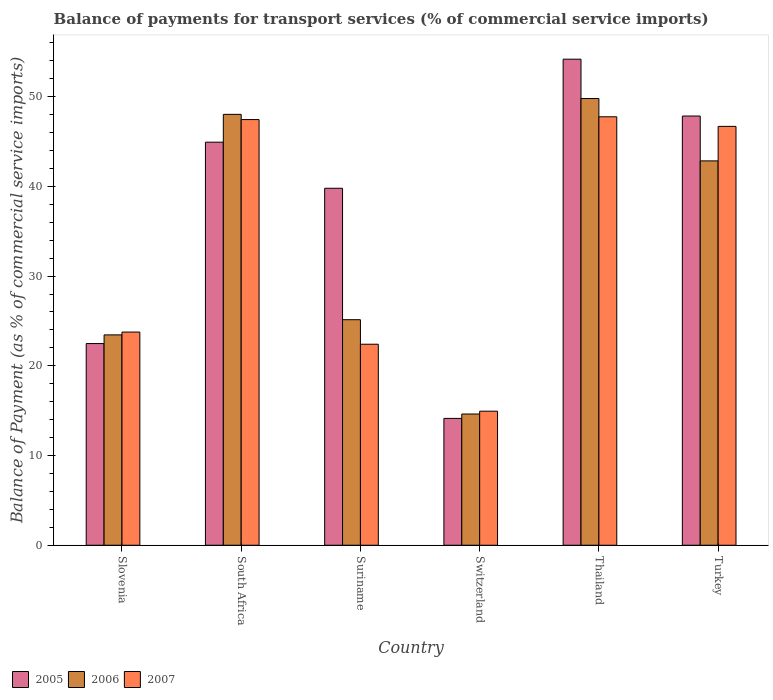How many groups of bars are there?
Offer a terse response. 6. Are the number of bars per tick equal to the number of legend labels?
Make the answer very short. Yes. How many bars are there on the 5th tick from the right?
Make the answer very short. 3. What is the label of the 4th group of bars from the left?
Your answer should be compact. Switzerland. In how many cases, is the number of bars for a given country not equal to the number of legend labels?
Your response must be concise. 0. What is the balance of payments for transport services in 2006 in South Africa?
Offer a terse response. 48.03. Across all countries, what is the maximum balance of payments for transport services in 2005?
Provide a succinct answer. 54.18. Across all countries, what is the minimum balance of payments for transport services in 2007?
Offer a terse response. 14.94. In which country was the balance of payments for transport services in 2006 maximum?
Offer a terse response. Thailand. In which country was the balance of payments for transport services in 2007 minimum?
Give a very brief answer. Switzerland. What is the total balance of payments for transport services in 2007 in the graph?
Offer a very short reply. 203. What is the difference between the balance of payments for transport services in 2006 in Switzerland and that in Turkey?
Make the answer very short. -28.21. What is the difference between the balance of payments for transport services in 2005 in Thailand and the balance of payments for transport services in 2007 in South Africa?
Give a very brief answer. 6.73. What is the average balance of payments for transport services in 2007 per country?
Offer a very short reply. 33.83. What is the difference between the balance of payments for transport services of/in 2006 and balance of payments for transport services of/in 2007 in Thailand?
Ensure brevity in your answer.  2.04. In how many countries, is the balance of payments for transport services in 2007 greater than 38 %?
Keep it short and to the point. 3. What is the ratio of the balance of payments for transport services in 2007 in Suriname to that in Turkey?
Ensure brevity in your answer.  0.48. Is the balance of payments for transport services in 2005 in Switzerland less than that in Turkey?
Offer a terse response. Yes. Is the difference between the balance of payments for transport services in 2006 in South Africa and Turkey greater than the difference between the balance of payments for transport services in 2007 in South Africa and Turkey?
Your answer should be very brief. Yes. What is the difference between the highest and the second highest balance of payments for transport services in 2006?
Your answer should be very brief. -1.77. What is the difference between the highest and the lowest balance of payments for transport services in 2007?
Your answer should be very brief. 32.82. In how many countries, is the balance of payments for transport services in 2007 greater than the average balance of payments for transport services in 2007 taken over all countries?
Keep it short and to the point. 3. What does the 2nd bar from the left in Slovenia represents?
Offer a terse response. 2006. How many bars are there?
Keep it short and to the point. 18. How many countries are there in the graph?
Offer a very short reply. 6. What is the difference between two consecutive major ticks on the Y-axis?
Your response must be concise. 10. Are the values on the major ticks of Y-axis written in scientific E-notation?
Your response must be concise. No. Where does the legend appear in the graph?
Keep it short and to the point. Bottom left. How many legend labels are there?
Give a very brief answer. 3. How are the legend labels stacked?
Offer a very short reply. Horizontal. What is the title of the graph?
Your response must be concise. Balance of payments for transport services (% of commercial service imports). What is the label or title of the Y-axis?
Your answer should be very brief. Balance of Payment (as % of commercial service imports). What is the Balance of Payment (as % of commercial service imports) of 2005 in Slovenia?
Provide a succinct answer. 22.48. What is the Balance of Payment (as % of commercial service imports) of 2006 in Slovenia?
Keep it short and to the point. 23.45. What is the Balance of Payment (as % of commercial service imports) of 2007 in Slovenia?
Your answer should be very brief. 23.76. What is the Balance of Payment (as % of commercial service imports) of 2005 in South Africa?
Ensure brevity in your answer.  44.93. What is the Balance of Payment (as % of commercial service imports) of 2006 in South Africa?
Your response must be concise. 48.03. What is the Balance of Payment (as % of commercial service imports) of 2007 in South Africa?
Provide a short and direct response. 47.45. What is the Balance of Payment (as % of commercial service imports) in 2005 in Suriname?
Your response must be concise. 39.79. What is the Balance of Payment (as % of commercial service imports) in 2006 in Suriname?
Offer a very short reply. 25.14. What is the Balance of Payment (as % of commercial service imports) in 2007 in Suriname?
Keep it short and to the point. 22.41. What is the Balance of Payment (as % of commercial service imports) in 2005 in Switzerland?
Ensure brevity in your answer.  14.14. What is the Balance of Payment (as % of commercial service imports) in 2006 in Switzerland?
Offer a terse response. 14.63. What is the Balance of Payment (as % of commercial service imports) in 2007 in Switzerland?
Offer a very short reply. 14.94. What is the Balance of Payment (as % of commercial service imports) in 2005 in Thailand?
Your answer should be very brief. 54.18. What is the Balance of Payment (as % of commercial service imports) of 2006 in Thailand?
Your answer should be compact. 49.79. What is the Balance of Payment (as % of commercial service imports) of 2007 in Thailand?
Provide a succinct answer. 47.76. What is the Balance of Payment (as % of commercial service imports) of 2005 in Turkey?
Give a very brief answer. 47.84. What is the Balance of Payment (as % of commercial service imports) of 2006 in Turkey?
Make the answer very short. 42.84. What is the Balance of Payment (as % of commercial service imports) in 2007 in Turkey?
Offer a very short reply. 46.69. Across all countries, what is the maximum Balance of Payment (as % of commercial service imports) of 2005?
Give a very brief answer. 54.18. Across all countries, what is the maximum Balance of Payment (as % of commercial service imports) in 2006?
Offer a very short reply. 49.79. Across all countries, what is the maximum Balance of Payment (as % of commercial service imports) of 2007?
Make the answer very short. 47.76. Across all countries, what is the minimum Balance of Payment (as % of commercial service imports) of 2005?
Offer a terse response. 14.14. Across all countries, what is the minimum Balance of Payment (as % of commercial service imports) of 2006?
Give a very brief answer. 14.63. Across all countries, what is the minimum Balance of Payment (as % of commercial service imports) of 2007?
Provide a short and direct response. 14.94. What is the total Balance of Payment (as % of commercial service imports) of 2005 in the graph?
Offer a very short reply. 223.36. What is the total Balance of Payment (as % of commercial service imports) of 2006 in the graph?
Your answer should be compact. 203.88. What is the total Balance of Payment (as % of commercial service imports) of 2007 in the graph?
Ensure brevity in your answer.  203. What is the difference between the Balance of Payment (as % of commercial service imports) of 2005 in Slovenia and that in South Africa?
Offer a very short reply. -22.45. What is the difference between the Balance of Payment (as % of commercial service imports) of 2006 in Slovenia and that in South Africa?
Offer a very short reply. -24.58. What is the difference between the Balance of Payment (as % of commercial service imports) of 2007 in Slovenia and that in South Africa?
Make the answer very short. -23.69. What is the difference between the Balance of Payment (as % of commercial service imports) of 2005 in Slovenia and that in Suriname?
Provide a succinct answer. -17.31. What is the difference between the Balance of Payment (as % of commercial service imports) in 2006 in Slovenia and that in Suriname?
Your answer should be very brief. -1.69. What is the difference between the Balance of Payment (as % of commercial service imports) of 2007 in Slovenia and that in Suriname?
Your answer should be compact. 1.35. What is the difference between the Balance of Payment (as % of commercial service imports) in 2005 in Slovenia and that in Switzerland?
Offer a very short reply. 8.34. What is the difference between the Balance of Payment (as % of commercial service imports) in 2006 in Slovenia and that in Switzerland?
Offer a very short reply. 8.82. What is the difference between the Balance of Payment (as % of commercial service imports) of 2007 in Slovenia and that in Switzerland?
Provide a succinct answer. 8.82. What is the difference between the Balance of Payment (as % of commercial service imports) of 2005 in Slovenia and that in Thailand?
Make the answer very short. -31.7. What is the difference between the Balance of Payment (as % of commercial service imports) in 2006 in Slovenia and that in Thailand?
Offer a terse response. -26.35. What is the difference between the Balance of Payment (as % of commercial service imports) of 2007 in Slovenia and that in Thailand?
Make the answer very short. -24. What is the difference between the Balance of Payment (as % of commercial service imports) in 2005 in Slovenia and that in Turkey?
Your answer should be compact. -25.36. What is the difference between the Balance of Payment (as % of commercial service imports) in 2006 in Slovenia and that in Turkey?
Your response must be concise. -19.4. What is the difference between the Balance of Payment (as % of commercial service imports) in 2007 in Slovenia and that in Turkey?
Offer a terse response. -22.93. What is the difference between the Balance of Payment (as % of commercial service imports) of 2005 in South Africa and that in Suriname?
Keep it short and to the point. 5.14. What is the difference between the Balance of Payment (as % of commercial service imports) in 2006 in South Africa and that in Suriname?
Ensure brevity in your answer.  22.89. What is the difference between the Balance of Payment (as % of commercial service imports) of 2007 in South Africa and that in Suriname?
Your answer should be very brief. 25.04. What is the difference between the Balance of Payment (as % of commercial service imports) in 2005 in South Africa and that in Switzerland?
Provide a succinct answer. 30.79. What is the difference between the Balance of Payment (as % of commercial service imports) in 2006 in South Africa and that in Switzerland?
Give a very brief answer. 33.4. What is the difference between the Balance of Payment (as % of commercial service imports) in 2007 in South Africa and that in Switzerland?
Ensure brevity in your answer.  32.51. What is the difference between the Balance of Payment (as % of commercial service imports) of 2005 in South Africa and that in Thailand?
Your answer should be compact. -9.25. What is the difference between the Balance of Payment (as % of commercial service imports) of 2006 in South Africa and that in Thailand?
Offer a very short reply. -1.77. What is the difference between the Balance of Payment (as % of commercial service imports) in 2007 in South Africa and that in Thailand?
Keep it short and to the point. -0.31. What is the difference between the Balance of Payment (as % of commercial service imports) in 2005 in South Africa and that in Turkey?
Your response must be concise. -2.91. What is the difference between the Balance of Payment (as % of commercial service imports) in 2006 in South Africa and that in Turkey?
Your answer should be very brief. 5.19. What is the difference between the Balance of Payment (as % of commercial service imports) in 2007 in South Africa and that in Turkey?
Your answer should be very brief. 0.76. What is the difference between the Balance of Payment (as % of commercial service imports) of 2005 in Suriname and that in Switzerland?
Provide a short and direct response. 25.65. What is the difference between the Balance of Payment (as % of commercial service imports) of 2006 in Suriname and that in Switzerland?
Provide a succinct answer. 10.51. What is the difference between the Balance of Payment (as % of commercial service imports) of 2007 in Suriname and that in Switzerland?
Offer a very short reply. 7.46. What is the difference between the Balance of Payment (as % of commercial service imports) in 2005 in Suriname and that in Thailand?
Offer a terse response. -14.39. What is the difference between the Balance of Payment (as % of commercial service imports) in 2006 in Suriname and that in Thailand?
Your response must be concise. -24.65. What is the difference between the Balance of Payment (as % of commercial service imports) in 2007 in Suriname and that in Thailand?
Give a very brief answer. -25.35. What is the difference between the Balance of Payment (as % of commercial service imports) in 2005 in Suriname and that in Turkey?
Your response must be concise. -8.05. What is the difference between the Balance of Payment (as % of commercial service imports) in 2006 in Suriname and that in Turkey?
Offer a terse response. -17.7. What is the difference between the Balance of Payment (as % of commercial service imports) in 2007 in Suriname and that in Turkey?
Ensure brevity in your answer.  -24.28. What is the difference between the Balance of Payment (as % of commercial service imports) in 2005 in Switzerland and that in Thailand?
Give a very brief answer. -40.04. What is the difference between the Balance of Payment (as % of commercial service imports) in 2006 in Switzerland and that in Thailand?
Keep it short and to the point. -35.17. What is the difference between the Balance of Payment (as % of commercial service imports) of 2007 in Switzerland and that in Thailand?
Give a very brief answer. -32.82. What is the difference between the Balance of Payment (as % of commercial service imports) of 2005 in Switzerland and that in Turkey?
Give a very brief answer. -33.7. What is the difference between the Balance of Payment (as % of commercial service imports) of 2006 in Switzerland and that in Turkey?
Your response must be concise. -28.21. What is the difference between the Balance of Payment (as % of commercial service imports) in 2007 in Switzerland and that in Turkey?
Your answer should be compact. -31.75. What is the difference between the Balance of Payment (as % of commercial service imports) in 2005 in Thailand and that in Turkey?
Provide a short and direct response. 6.34. What is the difference between the Balance of Payment (as % of commercial service imports) in 2006 in Thailand and that in Turkey?
Provide a succinct answer. 6.95. What is the difference between the Balance of Payment (as % of commercial service imports) of 2007 in Thailand and that in Turkey?
Make the answer very short. 1.07. What is the difference between the Balance of Payment (as % of commercial service imports) in 2005 in Slovenia and the Balance of Payment (as % of commercial service imports) in 2006 in South Africa?
Make the answer very short. -25.55. What is the difference between the Balance of Payment (as % of commercial service imports) of 2005 in Slovenia and the Balance of Payment (as % of commercial service imports) of 2007 in South Africa?
Your answer should be very brief. -24.97. What is the difference between the Balance of Payment (as % of commercial service imports) of 2006 in Slovenia and the Balance of Payment (as % of commercial service imports) of 2007 in South Africa?
Ensure brevity in your answer.  -24. What is the difference between the Balance of Payment (as % of commercial service imports) of 2005 in Slovenia and the Balance of Payment (as % of commercial service imports) of 2006 in Suriname?
Make the answer very short. -2.66. What is the difference between the Balance of Payment (as % of commercial service imports) in 2005 in Slovenia and the Balance of Payment (as % of commercial service imports) in 2007 in Suriname?
Offer a very short reply. 0.07. What is the difference between the Balance of Payment (as % of commercial service imports) in 2006 in Slovenia and the Balance of Payment (as % of commercial service imports) in 2007 in Suriname?
Give a very brief answer. 1.04. What is the difference between the Balance of Payment (as % of commercial service imports) of 2005 in Slovenia and the Balance of Payment (as % of commercial service imports) of 2006 in Switzerland?
Make the answer very short. 7.85. What is the difference between the Balance of Payment (as % of commercial service imports) in 2005 in Slovenia and the Balance of Payment (as % of commercial service imports) in 2007 in Switzerland?
Offer a very short reply. 7.54. What is the difference between the Balance of Payment (as % of commercial service imports) in 2006 in Slovenia and the Balance of Payment (as % of commercial service imports) in 2007 in Switzerland?
Your response must be concise. 8.51. What is the difference between the Balance of Payment (as % of commercial service imports) of 2005 in Slovenia and the Balance of Payment (as % of commercial service imports) of 2006 in Thailand?
Your answer should be very brief. -27.31. What is the difference between the Balance of Payment (as % of commercial service imports) of 2005 in Slovenia and the Balance of Payment (as % of commercial service imports) of 2007 in Thailand?
Keep it short and to the point. -25.28. What is the difference between the Balance of Payment (as % of commercial service imports) of 2006 in Slovenia and the Balance of Payment (as % of commercial service imports) of 2007 in Thailand?
Your answer should be very brief. -24.31. What is the difference between the Balance of Payment (as % of commercial service imports) of 2005 in Slovenia and the Balance of Payment (as % of commercial service imports) of 2006 in Turkey?
Your answer should be compact. -20.36. What is the difference between the Balance of Payment (as % of commercial service imports) of 2005 in Slovenia and the Balance of Payment (as % of commercial service imports) of 2007 in Turkey?
Offer a terse response. -24.21. What is the difference between the Balance of Payment (as % of commercial service imports) of 2006 in Slovenia and the Balance of Payment (as % of commercial service imports) of 2007 in Turkey?
Make the answer very short. -23.24. What is the difference between the Balance of Payment (as % of commercial service imports) in 2005 in South Africa and the Balance of Payment (as % of commercial service imports) in 2006 in Suriname?
Give a very brief answer. 19.79. What is the difference between the Balance of Payment (as % of commercial service imports) in 2005 in South Africa and the Balance of Payment (as % of commercial service imports) in 2007 in Suriname?
Keep it short and to the point. 22.52. What is the difference between the Balance of Payment (as % of commercial service imports) of 2006 in South Africa and the Balance of Payment (as % of commercial service imports) of 2007 in Suriname?
Your answer should be compact. 25.62. What is the difference between the Balance of Payment (as % of commercial service imports) of 2005 in South Africa and the Balance of Payment (as % of commercial service imports) of 2006 in Switzerland?
Provide a succinct answer. 30.3. What is the difference between the Balance of Payment (as % of commercial service imports) of 2005 in South Africa and the Balance of Payment (as % of commercial service imports) of 2007 in Switzerland?
Your answer should be very brief. 29.99. What is the difference between the Balance of Payment (as % of commercial service imports) in 2006 in South Africa and the Balance of Payment (as % of commercial service imports) in 2007 in Switzerland?
Your answer should be compact. 33.09. What is the difference between the Balance of Payment (as % of commercial service imports) in 2005 in South Africa and the Balance of Payment (as % of commercial service imports) in 2006 in Thailand?
Your answer should be very brief. -4.87. What is the difference between the Balance of Payment (as % of commercial service imports) of 2005 in South Africa and the Balance of Payment (as % of commercial service imports) of 2007 in Thailand?
Your answer should be very brief. -2.83. What is the difference between the Balance of Payment (as % of commercial service imports) in 2006 in South Africa and the Balance of Payment (as % of commercial service imports) in 2007 in Thailand?
Give a very brief answer. 0.27. What is the difference between the Balance of Payment (as % of commercial service imports) in 2005 in South Africa and the Balance of Payment (as % of commercial service imports) in 2006 in Turkey?
Give a very brief answer. 2.09. What is the difference between the Balance of Payment (as % of commercial service imports) of 2005 in South Africa and the Balance of Payment (as % of commercial service imports) of 2007 in Turkey?
Your response must be concise. -1.76. What is the difference between the Balance of Payment (as % of commercial service imports) of 2006 in South Africa and the Balance of Payment (as % of commercial service imports) of 2007 in Turkey?
Your response must be concise. 1.34. What is the difference between the Balance of Payment (as % of commercial service imports) in 2005 in Suriname and the Balance of Payment (as % of commercial service imports) in 2006 in Switzerland?
Offer a terse response. 25.16. What is the difference between the Balance of Payment (as % of commercial service imports) of 2005 in Suriname and the Balance of Payment (as % of commercial service imports) of 2007 in Switzerland?
Provide a succinct answer. 24.85. What is the difference between the Balance of Payment (as % of commercial service imports) in 2006 in Suriname and the Balance of Payment (as % of commercial service imports) in 2007 in Switzerland?
Offer a very short reply. 10.2. What is the difference between the Balance of Payment (as % of commercial service imports) of 2005 in Suriname and the Balance of Payment (as % of commercial service imports) of 2006 in Thailand?
Offer a very short reply. -10. What is the difference between the Balance of Payment (as % of commercial service imports) of 2005 in Suriname and the Balance of Payment (as % of commercial service imports) of 2007 in Thailand?
Ensure brevity in your answer.  -7.97. What is the difference between the Balance of Payment (as % of commercial service imports) in 2006 in Suriname and the Balance of Payment (as % of commercial service imports) in 2007 in Thailand?
Provide a succinct answer. -22.62. What is the difference between the Balance of Payment (as % of commercial service imports) of 2005 in Suriname and the Balance of Payment (as % of commercial service imports) of 2006 in Turkey?
Ensure brevity in your answer.  -3.05. What is the difference between the Balance of Payment (as % of commercial service imports) of 2005 in Suriname and the Balance of Payment (as % of commercial service imports) of 2007 in Turkey?
Provide a succinct answer. -6.9. What is the difference between the Balance of Payment (as % of commercial service imports) of 2006 in Suriname and the Balance of Payment (as % of commercial service imports) of 2007 in Turkey?
Your answer should be very brief. -21.55. What is the difference between the Balance of Payment (as % of commercial service imports) in 2005 in Switzerland and the Balance of Payment (as % of commercial service imports) in 2006 in Thailand?
Give a very brief answer. -35.66. What is the difference between the Balance of Payment (as % of commercial service imports) of 2005 in Switzerland and the Balance of Payment (as % of commercial service imports) of 2007 in Thailand?
Offer a very short reply. -33.62. What is the difference between the Balance of Payment (as % of commercial service imports) in 2006 in Switzerland and the Balance of Payment (as % of commercial service imports) in 2007 in Thailand?
Provide a short and direct response. -33.13. What is the difference between the Balance of Payment (as % of commercial service imports) of 2005 in Switzerland and the Balance of Payment (as % of commercial service imports) of 2006 in Turkey?
Make the answer very short. -28.7. What is the difference between the Balance of Payment (as % of commercial service imports) of 2005 in Switzerland and the Balance of Payment (as % of commercial service imports) of 2007 in Turkey?
Keep it short and to the point. -32.55. What is the difference between the Balance of Payment (as % of commercial service imports) of 2006 in Switzerland and the Balance of Payment (as % of commercial service imports) of 2007 in Turkey?
Keep it short and to the point. -32.06. What is the difference between the Balance of Payment (as % of commercial service imports) in 2005 in Thailand and the Balance of Payment (as % of commercial service imports) in 2006 in Turkey?
Make the answer very short. 11.34. What is the difference between the Balance of Payment (as % of commercial service imports) of 2005 in Thailand and the Balance of Payment (as % of commercial service imports) of 2007 in Turkey?
Your answer should be compact. 7.49. What is the difference between the Balance of Payment (as % of commercial service imports) in 2006 in Thailand and the Balance of Payment (as % of commercial service imports) in 2007 in Turkey?
Give a very brief answer. 3.11. What is the average Balance of Payment (as % of commercial service imports) in 2005 per country?
Provide a succinct answer. 37.23. What is the average Balance of Payment (as % of commercial service imports) of 2006 per country?
Your answer should be compact. 33.98. What is the average Balance of Payment (as % of commercial service imports) of 2007 per country?
Provide a succinct answer. 33.83. What is the difference between the Balance of Payment (as % of commercial service imports) in 2005 and Balance of Payment (as % of commercial service imports) in 2006 in Slovenia?
Provide a succinct answer. -0.97. What is the difference between the Balance of Payment (as % of commercial service imports) of 2005 and Balance of Payment (as % of commercial service imports) of 2007 in Slovenia?
Make the answer very short. -1.28. What is the difference between the Balance of Payment (as % of commercial service imports) in 2006 and Balance of Payment (as % of commercial service imports) in 2007 in Slovenia?
Make the answer very short. -0.31. What is the difference between the Balance of Payment (as % of commercial service imports) in 2005 and Balance of Payment (as % of commercial service imports) in 2006 in South Africa?
Offer a terse response. -3.1. What is the difference between the Balance of Payment (as % of commercial service imports) of 2005 and Balance of Payment (as % of commercial service imports) of 2007 in South Africa?
Your answer should be very brief. -2.52. What is the difference between the Balance of Payment (as % of commercial service imports) in 2006 and Balance of Payment (as % of commercial service imports) in 2007 in South Africa?
Provide a succinct answer. 0.58. What is the difference between the Balance of Payment (as % of commercial service imports) in 2005 and Balance of Payment (as % of commercial service imports) in 2006 in Suriname?
Give a very brief answer. 14.65. What is the difference between the Balance of Payment (as % of commercial service imports) of 2005 and Balance of Payment (as % of commercial service imports) of 2007 in Suriname?
Keep it short and to the point. 17.38. What is the difference between the Balance of Payment (as % of commercial service imports) in 2006 and Balance of Payment (as % of commercial service imports) in 2007 in Suriname?
Provide a short and direct response. 2.73. What is the difference between the Balance of Payment (as % of commercial service imports) of 2005 and Balance of Payment (as % of commercial service imports) of 2006 in Switzerland?
Provide a short and direct response. -0.49. What is the difference between the Balance of Payment (as % of commercial service imports) of 2005 and Balance of Payment (as % of commercial service imports) of 2007 in Switzerland?
Offer a very short reply. -0.8. What is the difference between the Balance of Payment (as % of commercial service imports) of 2006 and Balance of Payment (as % of commercial service imports) of 2007 in Switzerland?
Your response must be concise. -0.31. What is the difference between the Balance of Payment (as % of commercial service imports) of 2005 and Balance of Payment (as % of commercial service imports) of 2006 in Thailand?
Make the answer very short. 4.39. What is the difference between the Balance of Payment (as % of commercial service imports) in 2005 and Balance of Payment (as % of commercial service imports) in 2007 in Thailand?
Keep it short and to the point. 6.42. What is the difference between the Balance of Payment (as % of commercial service imports) in 2006 and Balance of Payment (as % of commercial service imports) in 2007 in Thailand?
Your response must be concise. 2.04. What is the difference between the Balance of Payment (as % of commercial service imports) of 2005 and Balance of Payment (as % of commercial service imports) of 2006 in Turkey?
Ensure brevity in your answer.  5. What is the difference between the Balance of Payment (as % of commercial service imports) of 2005 and Balance of Payment (as % of commercial service imports) of 2007 in Turkey?
Offer a terse response. 1.15. What is the difference between the Balance of Payment (as % of commercial service imports) in 2006 and Balance of Payment (as % of commercial service imports) in 2007 in Turkey?
Your answer should be compact. -3.85. What is the ratio of the Balance of Payment (as % of commercial service imports) in 2005 in Slovenia to that in South Africa?
Give a very brief answer. 0.5. What is the ratio of the Balance of Payment (as % of commercial service imports) of 2006 in Slovenia to that in South Africa?
Keep it short and to the point. 0.49. What is the ratio of the Balance of Payment (as % of commercial service imports) of 2007 in Slovenia to that in South Africa?
Your answer should be compact. 0.5. What is the ratio of the Balance of Payment (as % of commercial service imports) in 2005 in Slovenia to that in Suriname?
Keep it short and to the point. 0.56. What is the ratio of the Balance of Payment (as % of commercial service imports) of 2006 in Slovenia to that in Suriname?
Offer a terse response. 0.93. What is the ratio of the Balance of Payment (as % of commercial service imports) of 2007 in Slovenia to that in Suriname?
Your response must be concise. 1.06. What is the ratio of the Balance of Payment (as % of commercial service imports) of 2005 in Slovenia to that in Switzerland?
Ensure brevity in your answer.  1.59. What is the ratio of the Balance of Payment (as % of commercial service imports) of 2006 in Slovenia to that in Switzerland?
Keep it short and to the point. 1.6. What is the ratio of the Balance of Payment (as % of commercial service imports) in 2007 in Slovenia to that in Switzerland?
Your response must be concise. 1.59. What is the ratio of the Balance of Payment (as % of commercial service imports) in 2005 in Slovenia to that in Thailand?
Ensure brevity in your answer.  0.41. What is the ratio of the Balance of Payment (as % of commercial service imports) in 2006 in Slovenia to that in Thailand?
Your answer should be very brief. 0.47. What is the ratio of the Balance of Payment (as % of commercial service imports) of 2007 in Slovenia to that in Thailand?
Offer a terse response. 0.5. What is the ratio of the Balance of Payment (as % of commercial service imports) of 2005 in Slovenia to that in Turkey?
Offer a terse response. 0.47. What is the ratio of the Balance of Payment (as % of commercial service imports) of 2006 in Slovenia to that in Turkey?
Offer a very short reply. 0.55. What is the ratio of the Balance of Payment (as % of commercial service imports) of 2007 in Slovenia to that in Turkey?
Offer a very short reply. 0.51. What is the ratio of the Balance of Payment (as % of commercial service imports) in 2005 in South Africa to that in Suriname?
Your response must be concise. 1.13. What is the ratio of the Balance of Payment (as % of commercial service imports) of 2006 in South Africa to that in Suriname?
Offer a very short reply. 1.91. What is the ratio of the Balance of Payment (as % of commercial service imports) in 2007 in South Africa to that in Suriname?
Keep it short and to the point. 2.12. What is the ratio of the Balance of Payment (as % of commercial service imports) of 2005 in South Africa to that in Switzerland?
Give a very brief answer. 3.18. What is the ratio of the Balance of Payment (as % of commercial service imports) in 2006 in South Africa to that in Switzerland?
Your answer should be very brief. 3.28. What is the ratio of the Balance of Payment (as % of commercial service imports) of 2007 in South Africa to that in Switzerland?
Your answer should be very brief. 3.18. What is the ratio of the Balance of Payment (as % of commercial service imports) in 2005 in South Africa to that in Thailand?
Keep it short and to the point. 0.83. What is the ratio of the Balance of Payment (as % of commercial service imports) of 2006 in South Africa to that in Thailand?
Provide a succinct answer. 0.96. What is the ratio of the Balance of Payment (as % of commercial service imports) in 2007 in South Africa to that in Thailand?
Offer a terse response. 0.99. What is the ratio of the Balance of Payment (as % of commercial service imports) in 2005 in South Africa to that in Turkey?
Provide a succinct answer. 0.94. What is the ratio of the Balance of Payment (as % of commercial service imports) of 2006 in South Africa to that in Turkey?
Provide a succinct answer. 1.12. What is the ratio of the Balance of Payment (as % of commercial service imports) of 2007 in South Africa to that in Turkey?
Ensure brevity in your answer.  1.02. What is the ratio of the Balance of Payment (as % of commercial service imports) in 2005 in Suriname to that in Switzerland?
Give a very brief answer. 2.81. What is the ratio of the Balance of Payment (as % of commercial service imports) of 2006 in Suriname to that in Switzerland?
Provide a succinct answer. 1.72. What is the ratio of the Balance of Payment (as % of commercial service imports) in 2007 in Suriname to that in Switzerland?
Your answer should be very brief. 1.5. What is the ratio of the Balance of Payment (as % of commercial service imports) in 2005 in Suriname to that in Thailand?
Your response must be concise. 0.73. What is the ratio of the Balance of Payment (as % of commercial service imports) in 2006 in Suriname to that in Thailand?
Your answer should be compact. 0.5. What is the ratio of the Balance of Payment (as % of commercial service imports) of 2007 in Suriname to that in Thailand?
Ensure brevity in your answer.  0.47. What is the ratio of the Balance of Payment (as % of commercial service imports) in 2005 in Suriname to that in Turkey?
Offer a very short reply. 0.83. What is the ratio of the Balance of Payment (as % of commercial service imports) in 2006 in Suriname to that in Turkey?
Provide a short and direct response. 0.59. What is the ratio of the Balance of Payment (as % of commercial service imports) of 2007 in Suriname to that in Turkey?
Make the answer very short. 0.48. What is the ratio of the Balance of Payment (as % of commercial service imports) in 2005 in Switzerland to that in Thailand?
Give a very brief answer. 0.26. What is the ratio of the Balance of Payment (as % of commercial service imports) of 2006 in Switzerland to that in Thailand?
Your response must be concise. 0.29. What is the ratio of the Balance of Payment (as % of commercial service imports) of 2007 in Switzerland to that in Thailand?
Give a very brief answer. 0.31. What is the ratio of the Balance of Payment (as % of commercial service imports) in 2005 in Switzerland to that in Turkey?
Give a very brief answer. 0.3. What is the ratio of the Balance of Payment (as % of commercial service imports) of 2006 in Switzerland to that in Turkey?
Give a very brief answer. 0.34. What is the ratio of the Balance of Payment (as % of commercial service imports) of 2007 in Switzerland to that in Turkey?
Offer a terse response. 0.32. What is the ratio of the Balance of Payment (as % of commercial service imports) of 2005 in Thailand to that in Turkey?
Give a very brief answer. 1.13. What is the ratio of the Balance of Payment (as % of commercial service imports) of 2006 in Thailand to that in Turkey?
Your answer should be very brief. 1.16. What is the ratio of the Balance of Payment (as % of commercial service imports) in 2007 in Thailand to that in Turkey?
Give a very brief answer. 1.02. What is the difference between the highest and the second highest Balance of Payment (as % of commercial service imports) in 2005?
Give a very brief answer. 6.34. What is the difference between the highest and the second highest Balance of Payment (as % of commercial service imports) of 2006?
Give a very brief answer. 1.77. What is the difference between the highest and the second highest Balance of Payment (as % of commercial service imports) in 2007?
Offer a terse response. 0.31. What is the difference between the highest and the lowest Balance of Payment (as % of commercial service imports) in 2005?
Make the answer very short. 40.04. What is the difference between the highest and the lowest Balance of Payment (as % of commercial service imports) in 2006?
Your response must be concise. 35.17. What is the difference between the highest and the lowest Balance of Payment (as % of commercial service imports) in 2007?
Ensure brevity in your answer.  32.82. 